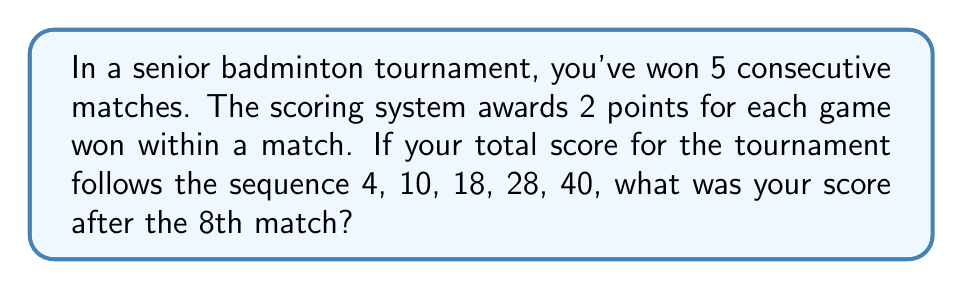Provide a solution to this math problem. Let's approach this step-by-step:

1) First, we need to identify the pattern in the given sequence:
   4, 10, 18, 28, 40

2) Let's calculate the differences between consecutive terms:
   10 - 4 = 6
   18 - 10 = 8
   28 - 18 = 10
   40 - 28 = 12

3) We can see that the difference is increasing by 2 each time:
   6, 8, 10, 12

4) This suggests a quadratic sequence. The general form of a quadratic sequence is:
   $$a_n = an^2 + bn + c$$
   where $n$ is the term number (1, 2, 3, ...) and $a$, $b$, and $c$ are constants.

5) Given that you win 2 points for each game, and $a_1 = 4$, we can deduce that $c = 2$ (you won 2 games in the first match).

6) Now, let's set up a system of equations using the first three terms:
   $$4 = a(1)^2 + b(1) + 2$$
   $$10 = a(2)^2 + b(2) + 2$$
   $$18 = a(3)^2 + b(3) + 2$$

7) Solving this system (which we'll skip for brevity), we get:
   $$a = 1, b = 1, c = 2$$

8) Therefore, the general term of the sequence is:
   $$a_n = n^2 + n + 2$$

9) To find the score after the 8th match, we substitute $n = 8$:
   $$a_8 = 8^2 + 8 + 2 = 64 + 8 + 2 = 74$$

Thus, your score after the 8th match would be 74 points.
Answer: 74 